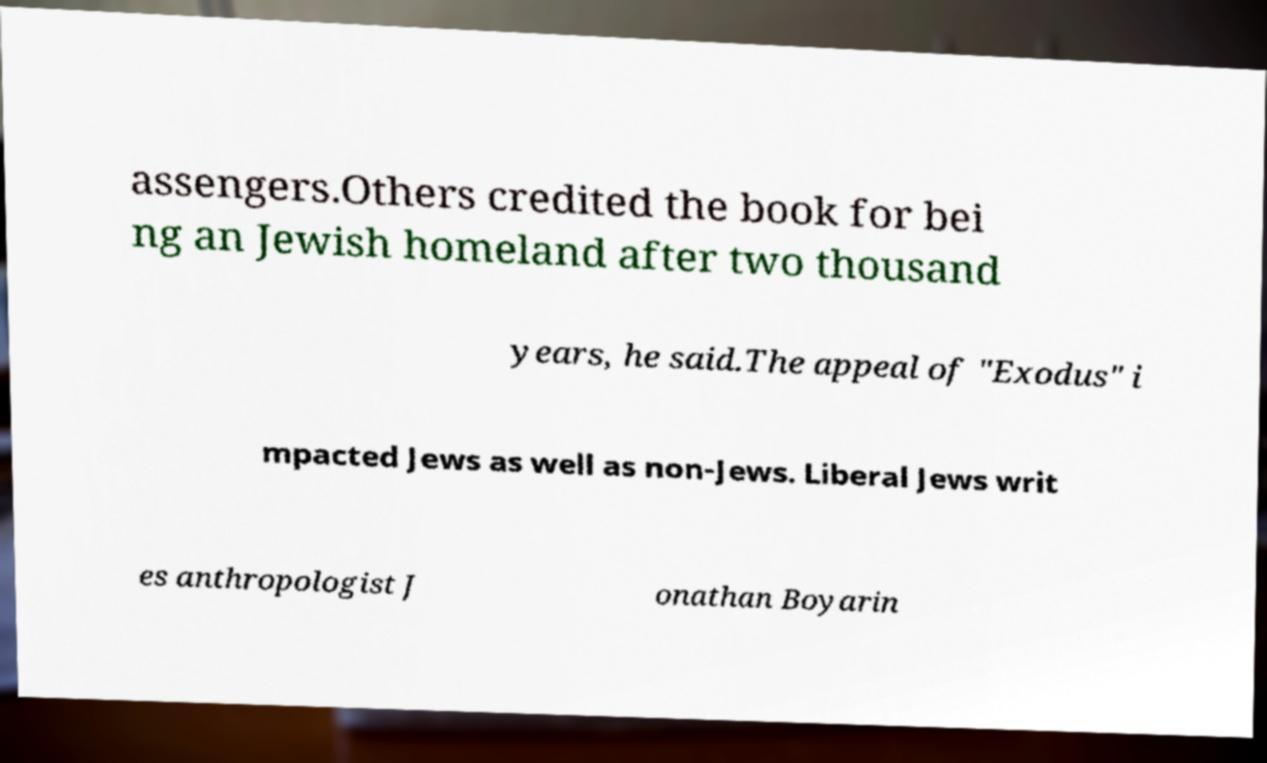For documentation purposes, I need the text within this image transcribed. Could you provide that? assengers.Others credited the book for bei ng an Jewish homeland after two thousand years, he said.The appeal of "Exodus" i mpacted Jews as well as non-Jews. Liberal Jews writ es anthropologist J onathan Boyarin 